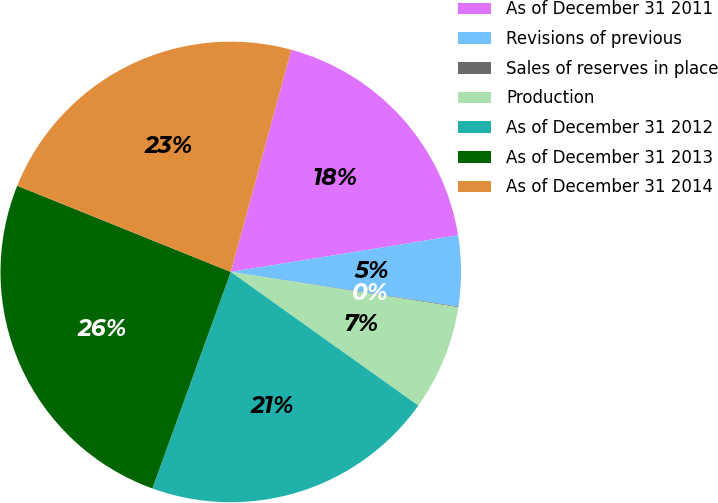Convert chart to OTSL. <chart><loc_0><loc_0><loc_500><loc_500><pie_chart><fcel>As of December 31 2011<fcel>Revisions of previous<fcel>Sales of reserves in place<fcel>Production<fcel>As of December 31 2012<fcel>As of December 31 2013<fcel>As of December 31 2014<nl><fcel>18.22%<fcel>4.95%<fcel>0.05%<fcel>7.4%<fcel>20.67%<fcel>25.57%<fcel>23.12%<nl></chart> 